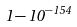Convert formula to latex. <formula><loc_0><loc_0><loc_500><loc_500>1 - 1 0 ^ { - 1 5 4 }</formula> 